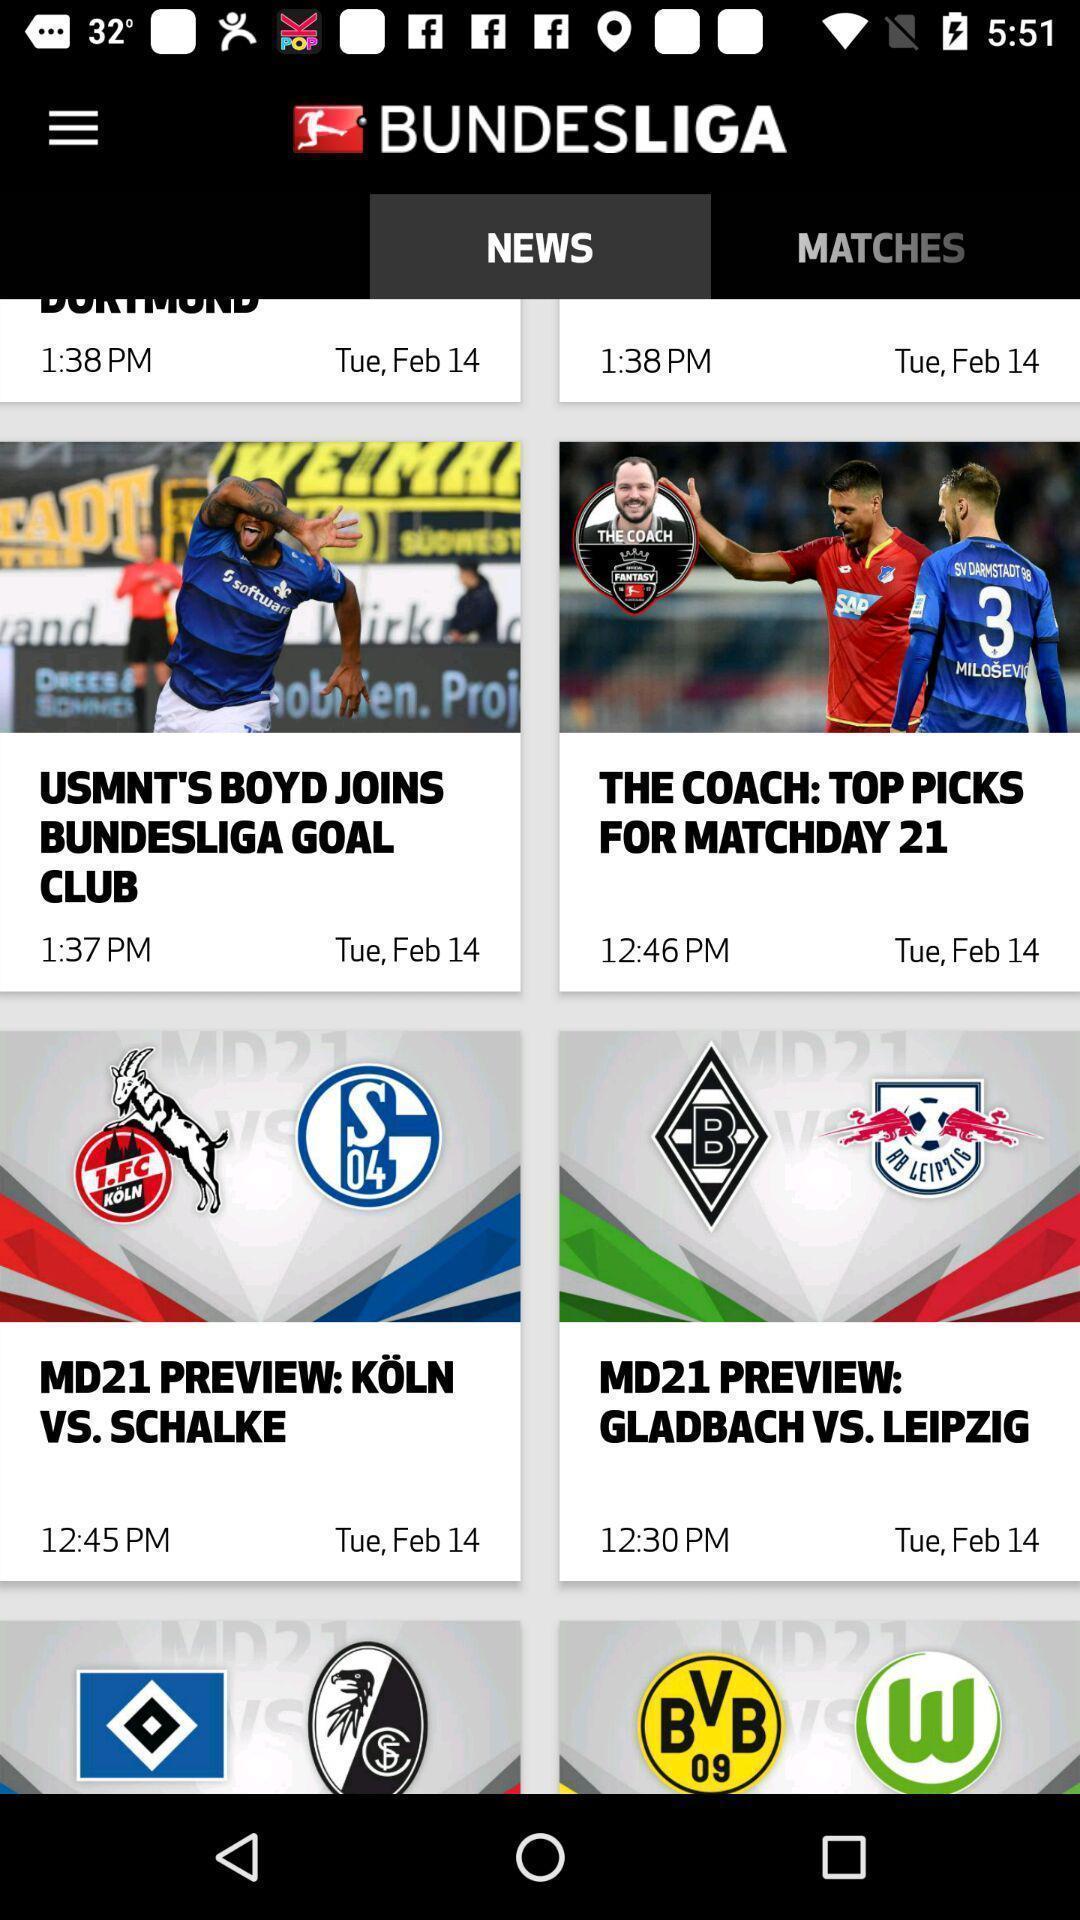What details can you identify in this image? Screen shows different news in news app. 